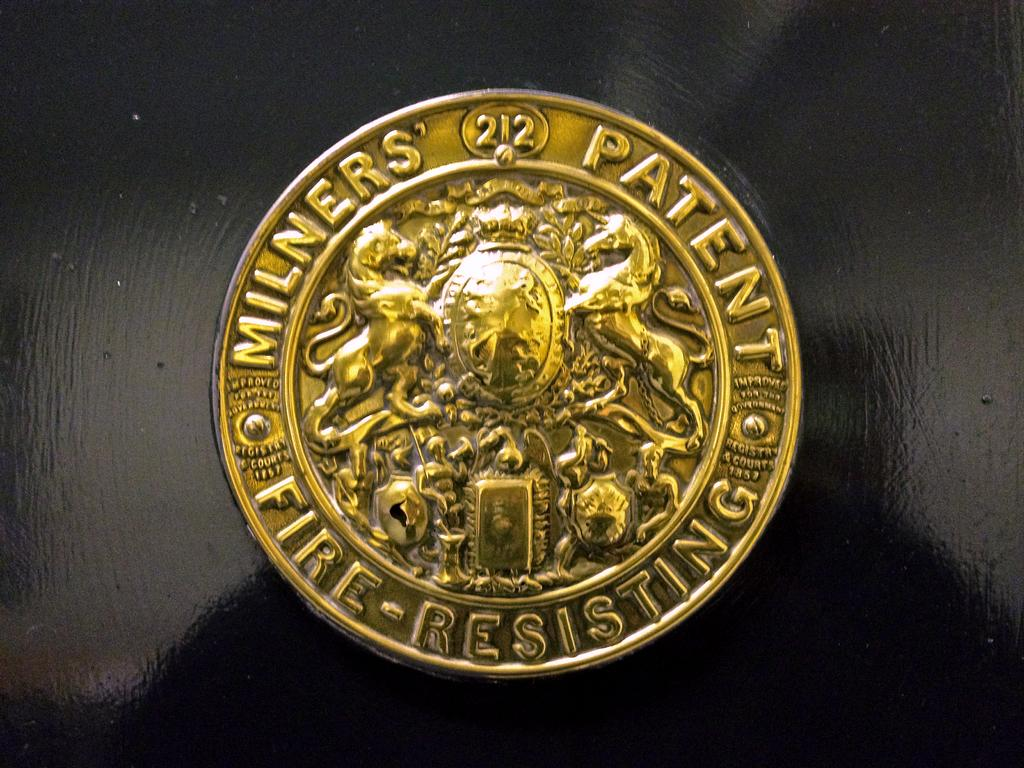<image>
Summarize the visual content of the image. a golden coin that says milners patent fire- resisting 